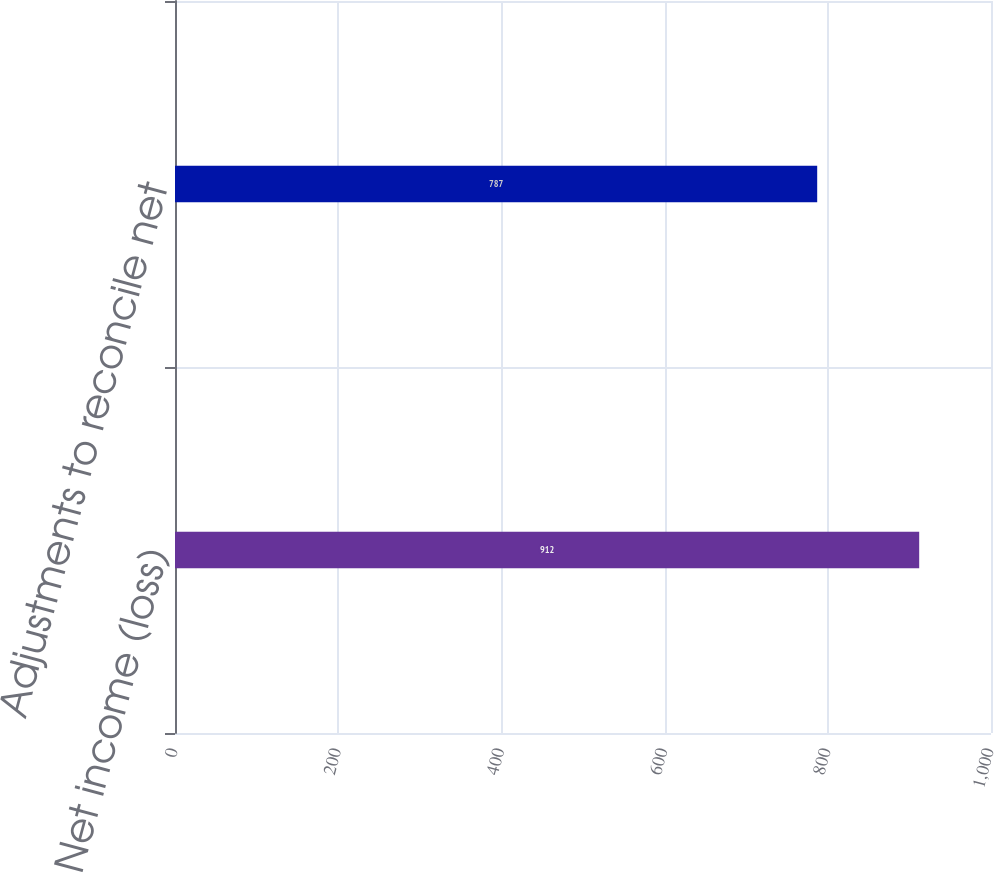Convert chart to OTSL. <chart><loc_0><loc_0><loc_500><loc_500><bar_chart><fcel>Net income (loss)<fcel>Adjustments to reconcile net<nl><fcel>912<fcel>787<nl></chart> 